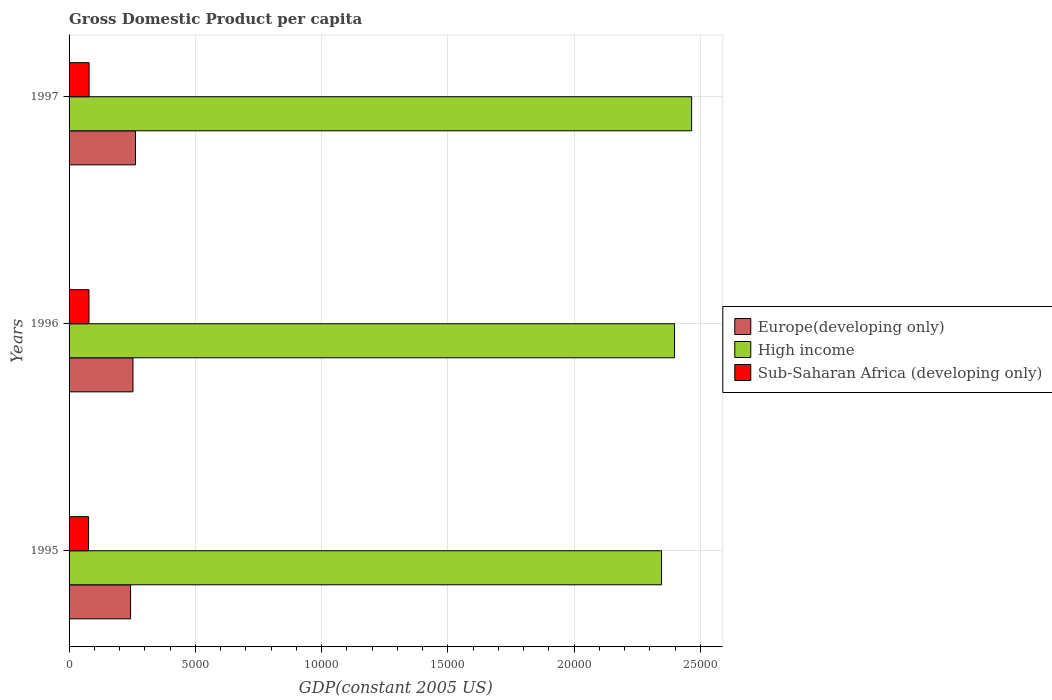How many groups of bars are there?
Provide a succinct answer. 3. Are the number of bars per tick equal to the number of legend labels?
Keep it short and to the point. Yes. What is the label of the 2nd group of bars from the top?
Provide a succinct answer. 1996. What is the GDP per capita in High income in 1996?
Give a very brief answer. 2.40e+04. Across all years, what is the maximum GDP per capita in Europe(developing only)?
Give a very brief answer. 2630.49. Across all years, what is the minimum GDP per capita in High income?
Provide a short and direct response. 2.35e+04. In which year was the GDP per capita in High income maximum?
Keep it short and to the point. 1997. What is the total GDP per capita in Sub-Saharan Africa (developing only) in the graph?
Your response must be concise. 2354.65. What is the difference between the GDP per capita in Sub-Saharan Africa (developing only) in 1995 and that in 1997?
Your answer should be compact. -20.96. What is the difference between the GDP per capita in Europe(developing only) in 1996 and the GDP per capita in High income in 1995?
Offer a terse response. -2.09e+04. What is the average GDP per capita in Sub-Saharan Africa (developing only) per year?
Offer a terse response. 784.88. In the year 1995, what is the difference between the GDP per capita in High income and GDP per capita in Sub-Saharan Africa (developing only)?
Your answer should be very brief. 2.27e+04. What is the ratio of the GDP per capita in High income in 1995 to that in 1996?
Provide a short and direct response. 0.98. Is the difference between the GDP per capita in High income in 1996 and 1997 greater than the difference between the GDP per capita in Sub-Saharan Africa (developing only) in 1996 and 1997?
Your response must be concise. No. What is the difference between the highest and the second highest GDP per capita in High income?
Your answer should be very brief. 676.31. What is the difference between the highest and the lowest GDP per capita in Sub-Saharan Africa (developing only)?
Your response must be concise. 20.96. In how many years, is the GDP per capita in High income greater than the average GDP per capita in High income taken over all years?
Your answer should be compact. 1. What does the 3rd bar from the top in 1997 represents?
Your answer should be compact. Europe(developing only). What is the difference between two consecutive major ticks on the X-axis?
Your response must be concise. 5000. Are the values on the major ticks of X-axis written in scientific E-notation?
Ensure brevity in your answer.  No. Where does the legend appear in the graph?
Provide a short and direct response. Center right. How many legend labels are there?
Offer a terse response. 3. What is the title of the graph?
Make the answer very short. Gross Domestic Product per capita. What is the label or title of the X-axis?
Your answer should be compact. GDP(constant 2005 US). What is the label or title of the Y-axis?
Your response must be concise. Years. What is the GDP(constant 2005 US) of Europe(developing only) in 1995?
Your response must be concise. 2435.33. What is the GDP(constant 2005 US) in High income in 1995?
Provide a succinct answer. 2.35e+04. What is the GDP(constant 2005 US) of Sub-Saharan Africa (developing only) in 1995?
Offer a very short reply. 772.34. What is the GDP(constant 2005 US) of Europe(developing only) in 1996?
Provide a short and direct response. 2531.4. What is the GDP(constant 2005 US) in High income in 1996?
Make the answer very short. 2.40e+04. What is the GDP(constant 2005 US) in Sub-Saharan Africa (developing only) in 1996?
Your answer should be very brief. 789. What is the GDP(constant 2005 US) of Europe(developing only) in 1997?
Give a very brief answer. 2630.49. What is the GDP(constant 2005 US) of High income in 1997?
Make the answer very short. 2.47e+04. What is the GDP(constant 2005 US) of Sub-Saharan Africa (developing only) in 1997?
Your answer should be very brief. 793.3. Across all years, what is the maximum GDP(constant 2005 US) in Europe(developing only)?
Provide a short and direct response. 2630.49. Across all years, what is the maximum GDP(constant 2005 US) in High income?
Ensure brevity in your answer.  2.47e+04. Across all years, what is the maximum GDP(constant 2005 US) of Sub-Saharan Africa (developing only)?
Your answer should be compact. 793.3. Across all years, what is the minimum GDP(constant 2005 US) in Europe(developing only)?
Provide a succinct answer. 2435.33. Across all years, what is the minimum GDP(constant 2005 US) of High income?
Keep it short and to the point. 2.35e+04. Across all years, what is the minimum GDP(constant 2005 US) of Sub-Saharan Africa (developing only)?
Provide a succinct answer. 772.34. What is the total GDP(constant 2005 US) in Europe(developing only) in the graph?
Give a very brief answer. 7597.22. What is the total GDP(constant 2005 US) in High income in the graph?
Make the answer very short. 7.21e+04. What is the total GDP(constant 2005 US) in Sub-Saharan Africa (developing only) in the graph?
Ensure brevity in your answer.  2354.65. What is the difference between the GDP(constant 2005 US) of Europe(developing only) in 1995 and that in 1996?
Make the answer very short. -96.07. What is the difference between the GDP(constant 2005 US) of High income in 1995 and that in 1996?
Your answer should be very brief. -515.21. What is the difference between the GDP(constant 2005 US) of Sub-Saharan Africa (developing only) in 1995 and that in 1996?
Your response must be concise. -16.66. What is the difference between the GDP(constant 2005 US) in Europe(developing only) in 1995 and that in 1997?
Provide a succinct answer. -195.16. What is the difference between the GDP(constant 2005 US) of High income in 1995 and that in 1997?
Offer a very short reply. -1191.52. What is the difference between the GDP(constant 2005 US) in Sub-Saharan Africa (developing only) in 1995 and that in 1997?
Your answer should be very brief. -20.96. What is the difference between the GDP(constant 2005 US) in Europe(developing only) in 1996 and that in 1997?
Your answer should be compact. -99.1. What is the difference between the GDP(constant 2005 US) of High income in 1996 and that in 1997?
Make the answer very short. -676.31. What is the difference between the GDP(constant 2005 US) in Sub-Saharan Africa (developing only) in 1996 and that in 1997?
Your response must be concise. -4.3. What is the difference between the GDP(constant 2005 US) of Europe(developing only) in 1995 and the GDP(constant 2005 US) of High income in 1996?
Provide a short and direct response. -2.15e+04. What is the difference between the GDP(constant 2005 US) of Europe(developing only) in 1995 and the GDP(constant 2005 US) of Sub-Saharan Africa (developing only) in 1996?
Provide a short and direct response. 1646.33. What is the difference between the GDP(constant 2005 US) of High income in 1995 and the GDP(constant 2005 US) of Sub-Saharan Africa (developing only) in 1996?
Offer a very short reply. 2.27e+04. What is the difference between the GDP(constant 2005 US) in Europe(developing only) in 1995 and the GDP(constant 2005 US) in High income in 1997?
Make the answer very short. -2.22e+04. What is the difference between the GDP(constant 2005 US) of Europe(developing only) in 1995 and the GDP(constant 2005 US) of Sub-Saharan Africa (developing only) in 1997?
Keep it short and to the point. 1642.03. What is the difference between the GDP(constant 2005 US) of High income in 1995 and the GDP(constant 2005 US) of Sub-Saharan Africa (developing only) in 1997?
Provide a short and direct response. 2.27e+04. What is the difference between the GDP(constant 2005 US) of Europe(developing only) in 1996 and the GDP(constant 2005 US) of High income in 1997?
Make the answer very short. -2.21e+04. What is the difference between the GDP(constant 2005 US) in Europe(developing only) in 1996 and the GDP(constant 2005 US) in Sub-Saharan Africa (developing only) in 1997?
Offer a terse response. 1738.09. What is the difference between the GDP(constant 2005 US) in High income in 1996 and the GDP(constant 2005 US) in Sub-Saharan Africa (developing only) in 1997?
Offer a very short reply. 2.32e+04. What is the average GDP(constant 2005 US) in Europe(developing only) per year?
Offer a very short reply. 2532.41. What is the average GDP(constant 2005 US) in High income per year?
Provide a short and direct response. 2.40e+04. What is the average GDP(constant 2005 US) of Sub-Saharan Africa (developing only) per year?
Offer a terse response. 784.88. In the year 1995, what is the difference between the GDP(constant 2005 US) of Europe(developing only) and GDP(constant 2005 US) of High income?
Make the answer very short. -2.10e+04. In the year 1995, what is the difference between the GDP(constant 2005 US) of Europe(developing only) and GDP(constant 2005 US) of Sub-Saharan Africa (developing only)?
Your answer should be very brief. 1662.99. In the year 1995, what is the difference between the GDP(constant 2005 US) of High income and GDP(constant 2005 US) of Sub-Saharan Africa (developing only)?
Ensure brevity in your answer.  2.27e+04. In the year 1996, what is the difference between the GDP(constant 2005 US) of Europe(developing only) and GDP(constant 2005 US) of High income?
Your answer should be compact. -2.15e+04. In the year 1996, what is the difference between the GDP(constant 2005 US) of Europe(developing only) and GDP(constant 2005 US) of Sub-Saharan Africa (developing only)?
Provide a succinct answer. 1742.39. In the year 1996, what is the difference between the GDP(constant 2005 US) of High income and GDP(constant 2005 US) of Sub-Saharan Africa (developing only)?
Make the answer very short. 2.32e+04. In the year 1997, what is the difference between the GDP(constant 2005 US) of Europe(developing only) and GDP(constant 2005 US) of High income?
Provide a succinct answer. -2.20e+04. In the year 1997, what is the difference between the GDP(constant 2005 US) in Europe(developing only) and GDP(constant 2005 US) in Sub-Saharan Africa (developing only)?
Your answer should be compact. 1837.19. In the year 1997, what is the difference between the GDP(constant 2005 US) of High income and GDP(constant 2005 US) of Sub-Saharan Africa (developing only)?
Keep it short and to the point. 2.39e+04. What is the ratio of the GDP(constant 2005 US) in Europe(developing only) in 1995 to that in 1996?
Offer a terse response. 0.96. What is the ratio of the GDP(constant 2005 US) of High income in 1995 to that in 1996?
Provide a short and direct response. 0.98. What is the ratio of the GDP(constant 2005 US) of Sub-Saharan Africa (developing only) in 1995 to that in 1996?
Give a very brief answer. 0.98. What is the ratio of the GDP(constant 2005 US) of Europe(developing only) in 1995 to that in 1997?
Your answer should be compact. 0.93. What is the ratio of the GDP(constant 2005 US) of High income in 1995 to that in 1997?
Offer a terse response. 0.95. What is the ratio of the GDP(constant 2005 US) in Sub-Saharan Africa (developing only) in 1995 to that in 1997?
Keep it short and to the point. 0.97. What is the ratio of the GDP(constant 2005 US) in Europe(developing only) in 1996 to that in 1997?
Ensure brevity in your answer.  0.96. What is the ratio of the GDP(constant 2005 US) of High income in 1996 to that in 1997?
Offer a very short reply. 0.97. What is the ratio of the GDP(constant 2005 US) of Sub-Saharan Africa (developing only) in 1996 to that in 1997?
Your response must be concise. 0.99. What is the difference between the highest and the second highest GDP(constant 2005 US) of Europe(developing only)?
Provide a short and direct response. 99.1. What is the difference between the highest and the second highest GDP(constant 2005 US) of High income?
Provide a short and direct response. 676.31. What is the difference between the highest and the second highest GDP(constant 2005 US) in Sub-Saharan Africa (developing only)?
Give a very brief answer. 4.3. What is the difference between the highest and the lowest GDP(constant 2005 US) of Europe(developing only)?
Your answer should be compact. 195.16. What is the difference between the highest and the lowest GDP(constant 2005 US) in High income?
Provide a succinct answer. 1191.52. What is the difference between the highest and the lowest GDP(constant 2005 US) in Sub-Saharan Africa (developing only)?
Offer a terse response. 20.96. 